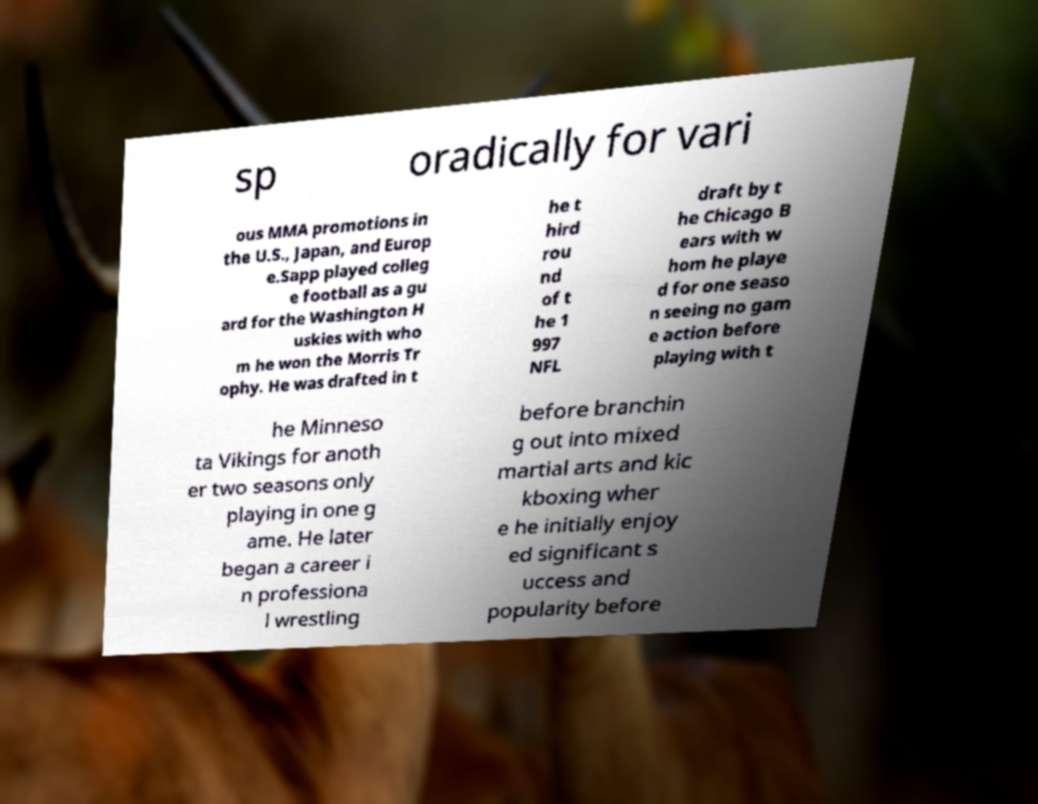Can you read and provide the text displayed in the image?This photo seems to have some interesting text. Can you extract and type it out for me? sp oradically for vari ous MMA promotions in the U.S., Japan, and Europ e.Sapp played colleg e football as a gu ard for the Washington H uskies with who m he won the Morris Tr ophy. He was drafted in t he t hird rou nd of t he 1 997 NFL draft by t he Chicago B ears with w hom he playe d for one seaso n seeing no gam e action before playing with t he Minneso ta Vikings for anoth er two seasons only playing in one g ame. He later began a career i n professiona l wrestling before branchin g out into mixed martial arts and kic kboxing wher e he initially enjoy ed significant s uccess and popularity before 